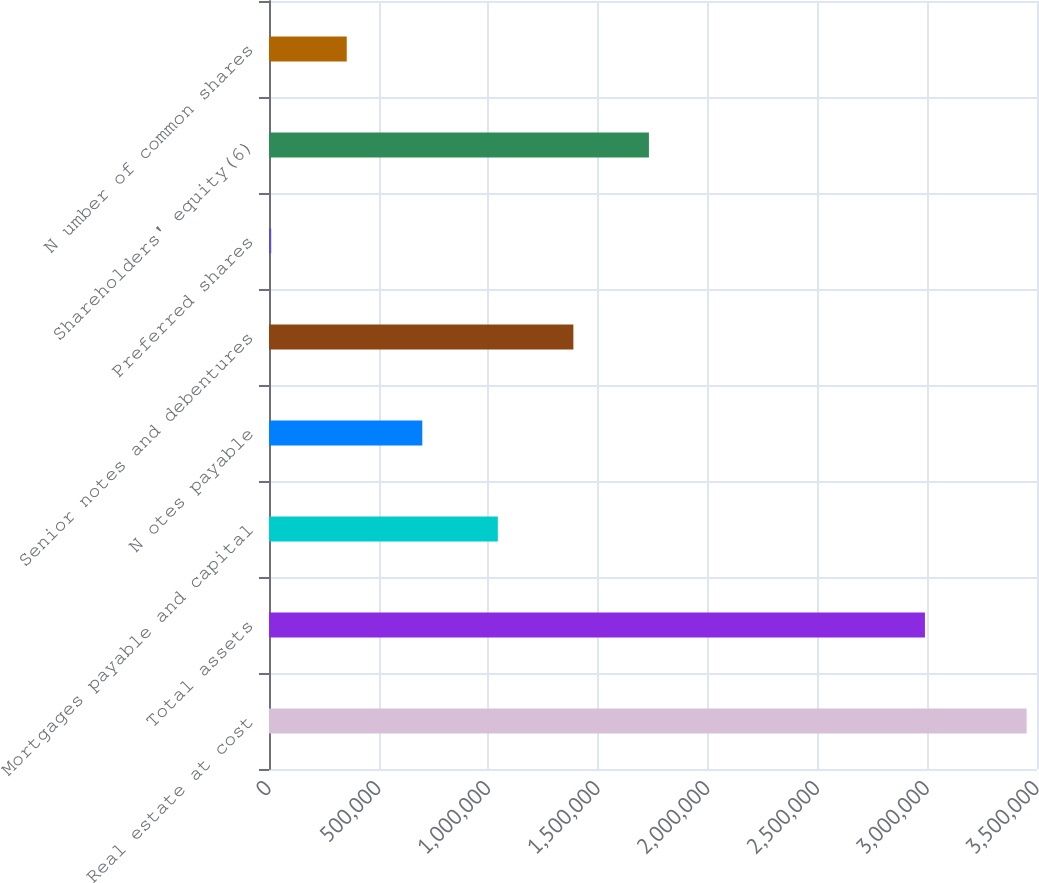Convert chart to OTSL. <chart><loc_0><loc_0><loc_500><loc_500><bar_chart><fcel>Real estate at cost<fcel>Total assets<fcel>Mortgages payable and capital<fcel>N otes payable<fcel>Senior notes and debentures<fcel>Preferred shares<fcel>Shareholders' equity(6)<fcel>N umber of common shares<nl><fcel>3.45285e+06<fcel>2.9893e+06<fcel>1.04285e+06<fcel>698567<fcel>1.38714e+06<fcel>9997<fcel>1.73142e+06<fcel>354282<nl></chart> 